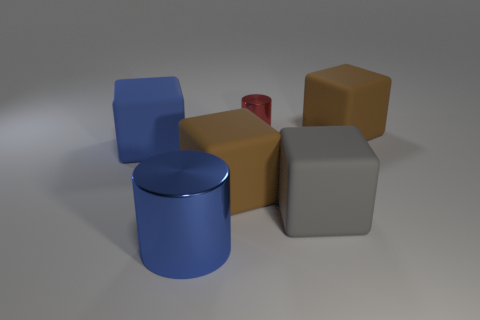How big is the object that is both behind the big blue rubber cube and in front of the tiny red metal cylinder?
Your answer should be compact. Large. Are there any matte objects of the same color as the tiny cylinder?
Offer a very short reply. No. What color is the big rubber block behind the big blue thing that is behind the gray rubber object?
Make the answer very short. Brown. Are there fewer tiny things to the left of the tiny cylinder than blue metallic things in front of the blue metallic cylinder?
Give a very brief answer. No. Does the gray block have the same size as the red cylinder?
Ensure brevity in your answer.  No. What shape is the object that is both left of the red metal object and right of the blue metallic cylinder?
Keep it short and to the point. Cube. What number of brown cubes are made of the same material as the gray block?
Provide a short and direct response. 2. There is a metal cylinder right of the large blue shiny thing; what number of small red objects are to the right of it?
Give a very brief answer. 0. There is a large brown rubber object that is to the left of the large matte object behind the block that is on the left side of the blue metallic object; what shape is it?
Give a very brief answer. Cube. There is a block that is the same color as the large metallic thing; what size is it?
Keep it short and to the point. Large. 